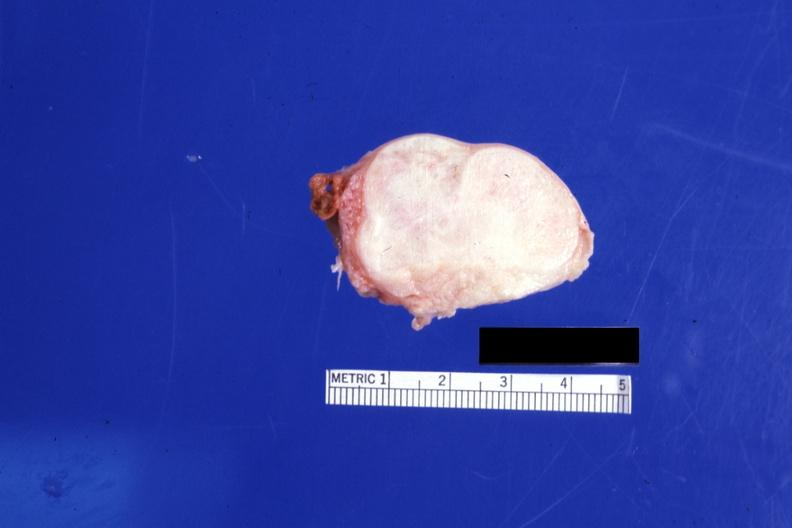does interesting case show cut surface 4 cm lesion 76yobf?
Answer the question using a single word or phrase. No 